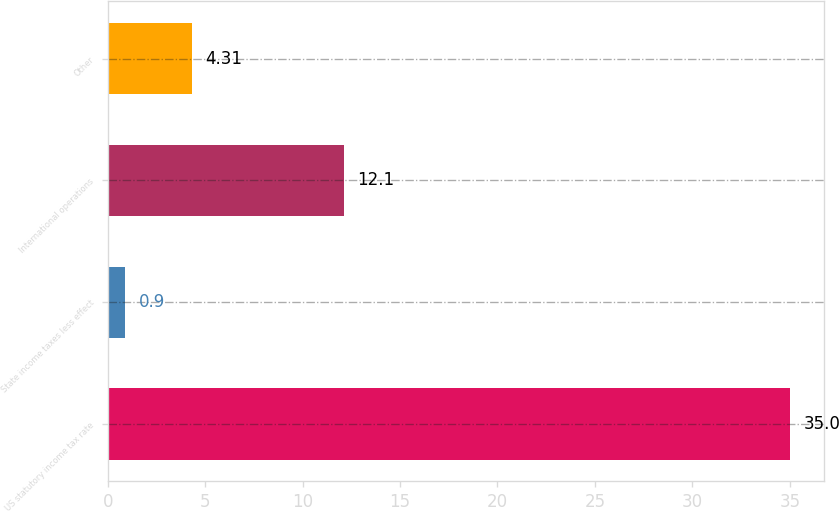Convert chart to OTSL. <chart><loc_0><loc_0><loc_500><loc_500><bar_chart><fcel>US statutory income tax rate<fcel>State income taxes less effect<fcel>International operations<fcel>Other<nl><fcel>35<fcel>0.9<fcel>12.1<fcel>4.31<nl></chart> 